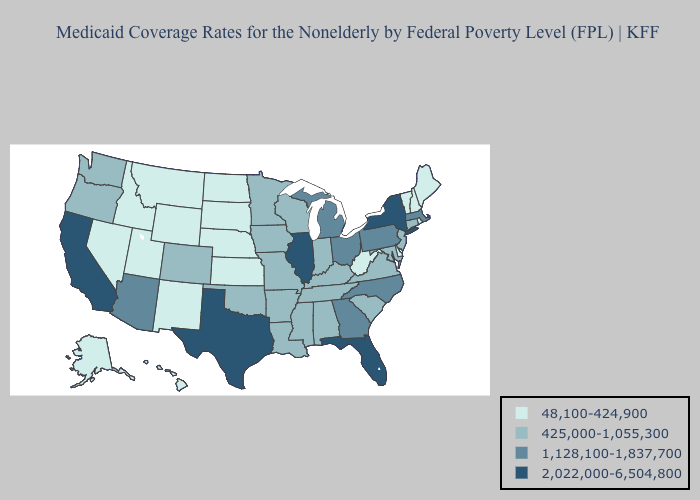Does Colorado have the highest value in the West?
Give a very brief answer. No. Does the map have missing data?
Be succinct. No. What is the lowest value in states that border Nebraska?
Quick response, please. 48,100-424,900. Which states have the lowest value in the USA?
Answer briefly. Alaska, Delaware, Hawaii, Idaho, Kansas, Maine, Montana, Nebraska, Nevada, New Hampshire, New Mexico, North Dakota, Rhode Island, South Dakota, Utah, Vermont, West Virginia, Wyoming. Name the states that have a value in the range 1,128,100-1,837,700?
Quick response, please. Arizona, Georgia, Massachusetts, Michigan, North Carolina, Ohio, Pennsylvania. What is the highest value in the South ?
Be succinct. 2,022,000-6,504,800. Does North Dakota have the lowest value in the MidWest?
Give a very brief answer. Yes. What is the value of Massachusetts?
Concise answer only. 1,128,100-1,837,700. What is the highest value in the Northeast ?
Quick response, please. 2,022,000-6,504,800. Does Texas have the highest value in the USA?
Write a very short answer. Yes. Name the states that have a value in the range 2,022,000-6,504,800?
Quick response, please. California, Florida, Illinois, New York, Texas. What is the highest value in the West ?
Write a very short answer. 2,022,000-6,504,800. Name the states that have a value in the range 2,022,000-6,504,800?
Give a very brief answer. California, Florida, Illinois, New York, Texas. Does Rhode Island have a lower value than Maryland?
Concise answer only. Yes. What is the highest value in the USA?
Short answer required. 2,022,000-6,504,800. 